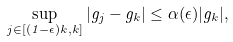Convert formula to latex. <formula><loc_0><loc_0><loc_500><loc_500>\sup _ { j \in [ ( 1 - \epsilon ) k , k ] } | g _ { j } - g _ { k } | \leq \alpha ( \epsilon ) | g _ { k } | ,</formula> 